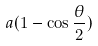<formula> <loc_0><loc_0><loc_500><loc_500>a ( 1 - \cos \frac { \theta } { 2 } )</formula> 